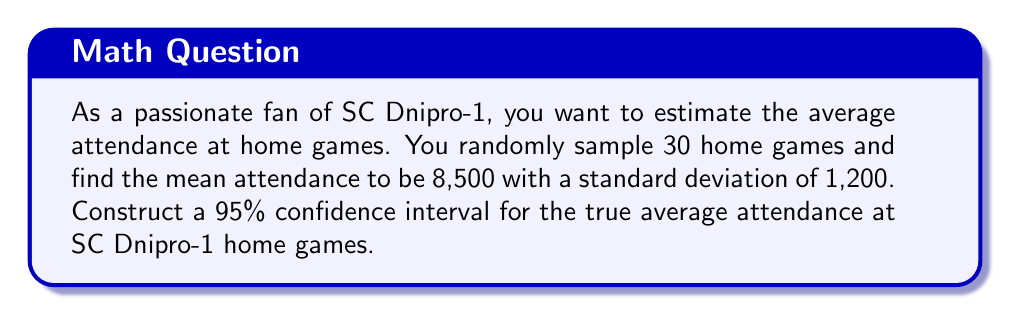What is the answer to this math problem? Let's approach this step-by-step:

1) We are given:
   - Sample size: $n = 30$
   - Sample mean: $\bar{x} = 8,500$
   - Sample standard deviation: $s = 1,200$
   - Confidence level: 95%

2) For a 95% confidence interval, we use a z-score of 1.96 (assuming normal distribution).

3) The formula for the confidence interval is:

   $$\bar{x} \pm z \cdot \frac{s}{\sqrt{n}}$$

4) Substituting our values:

   $$8,500 \pm 1.96 \cdot \frac{1,200}{\sqrt{30}}$$

5) Simplify:
   $$8,500 \pm 1.96 \cdot \frac{1,200}{5.477}$$
   $$8,500 \pm 1.96 \cdot 219.1$$
   $$8,500 \pm 429.4$$

6) Therefore, the confidence interval is:
   $$(8,500 - 429.4, 8,500 + 429.4)$$
   $$(8,070.6, 8,929.4)$$

7) Rounding to whole numbers (as we're dealing with people):
   $$(8,071, 8,929)$$
Answer: (8,071, 8,929) 